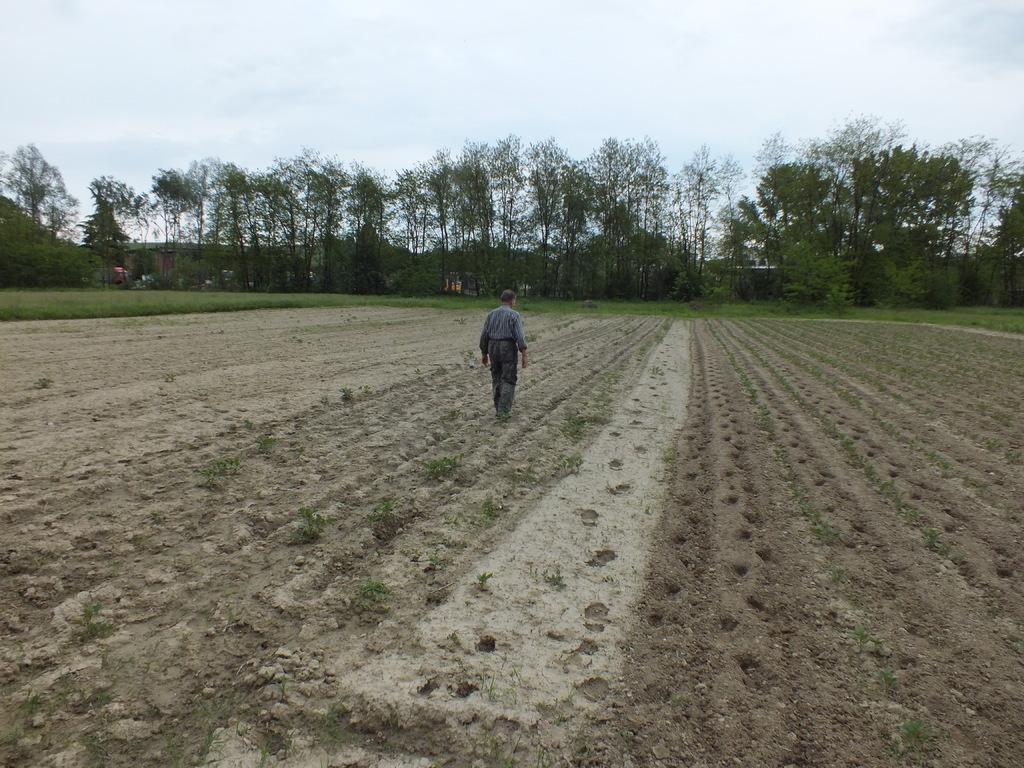Can you describe this image briefly? In this picture there is a person walking on the ground and we can see green grass. In the background of the image we can see trees and sky. 